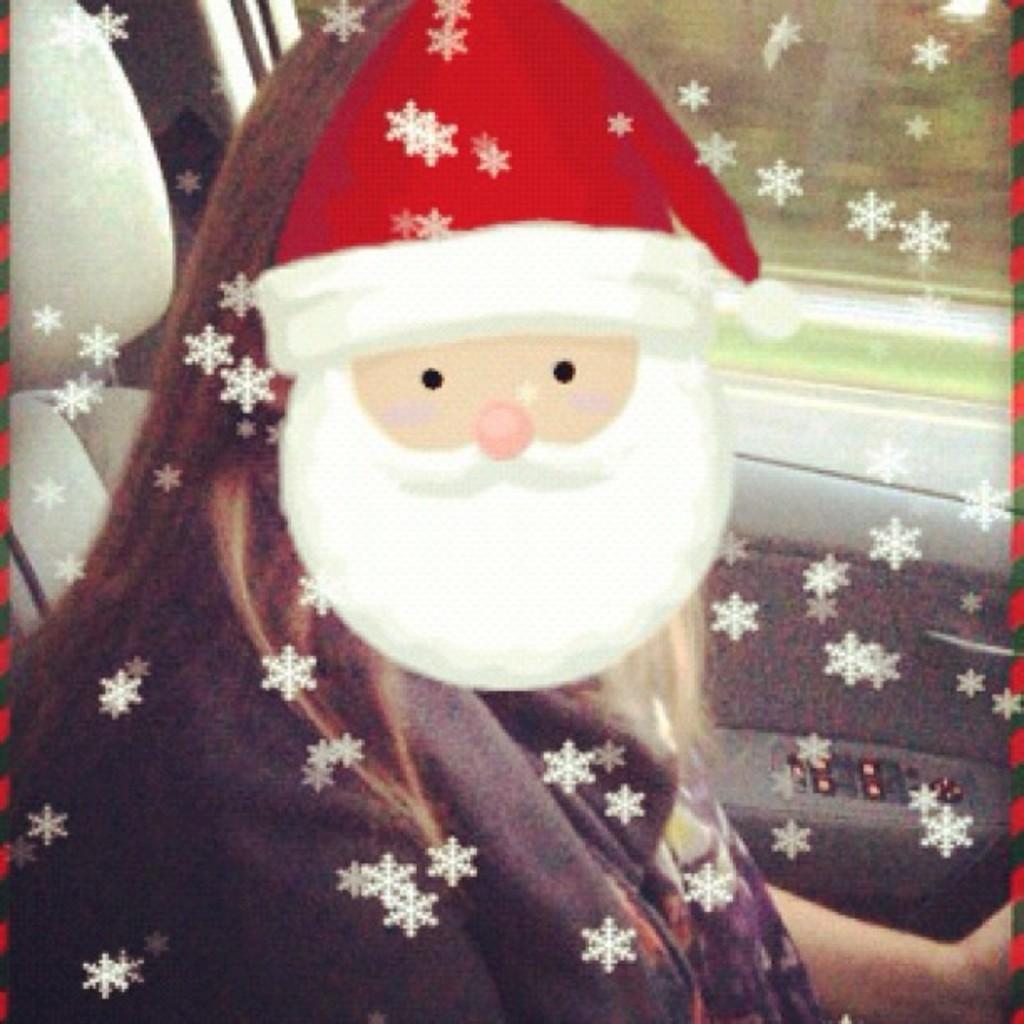Please provide a concise description of this image. In the picture I can see a person is sitting in the car. I can also see a cartoon face on the image. 